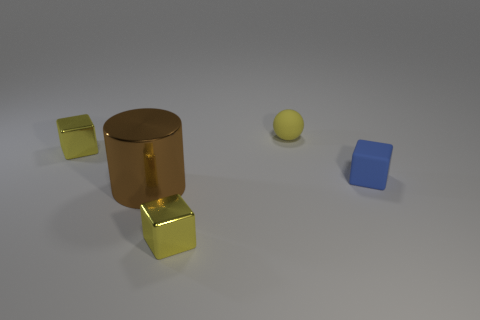Add 2 large objects. How many objects exist? 7 Subtract all cylinders. How many objects are left? 4 Add 2 blocks. How many blocks exist? 5 Subtract 0 green spheres. How many objects are left? 5 Subtract all tiny green balls. Subtract all small blue objects. How many objects are left? 4 Add 3 tiny blue rubber blocks. How many tiny blue rubber blocks are left? 4 